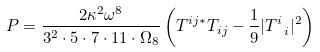<formula> <loc_0><loc_0><loc_500><loc_500>P = \frac { 2 \kappa ^ { 2 } \omega ^ { 8 } } { 3 ^ { 2 } \cdot 5 \cdot 7 \cdot 1 1 \cdot \Omega _ { 8 } } \left ( T ^ { i j * } T _ { i j } - \frac { 1 } { 9 } | T ^ { i } _ { \ i } | ^ { 2 } \right )</formula> 